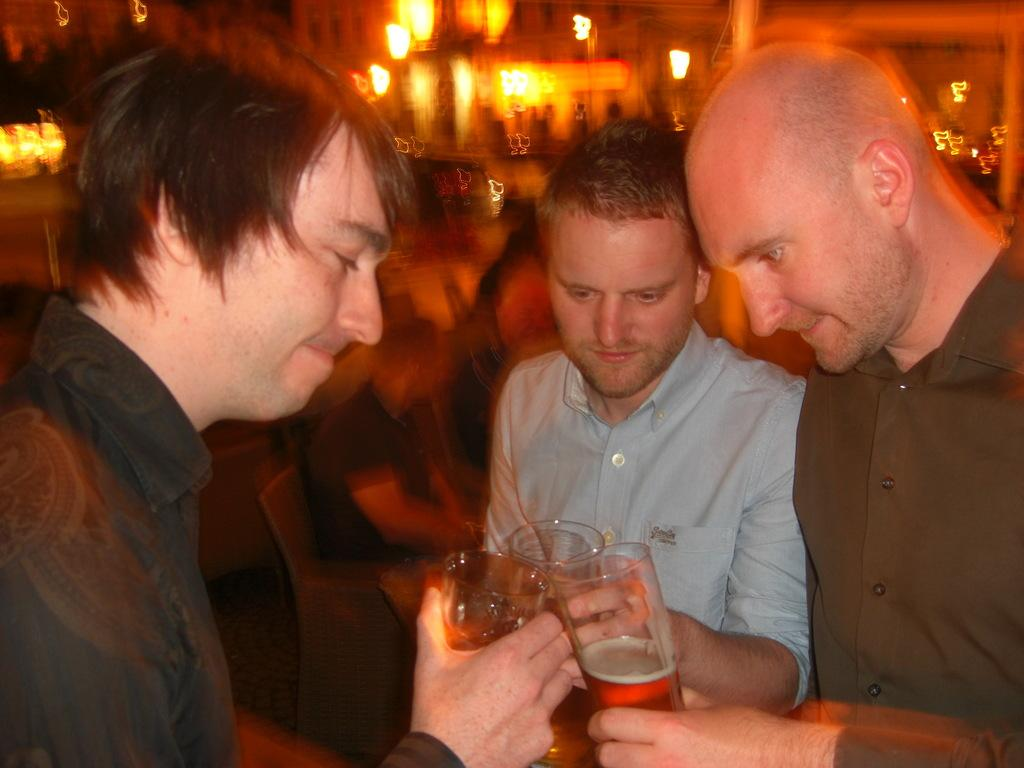How many people are present in the image? There are three persons in the image. What are the people holding in their hands? Each person is holding a glass. What type of industry is being discussed by the people in the image? There is no discussion or indication of an industry in the image; the people are simply holding glasses. 